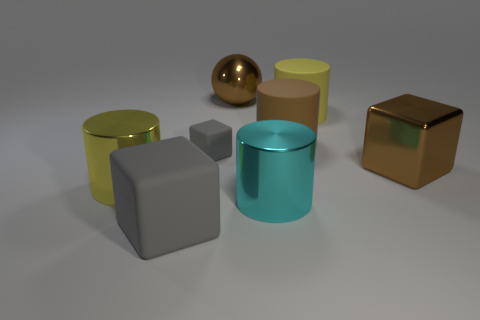Add 1 large brown metallic balls. How many objects exist? 9 Subtract all balls. How many objects are left? 7 Subtract 0 blue cylinders. How many objects are left? 8 Subtract all brown metallic blocks. Subtract all red metallic cubes. How many objects are left? 7 Add 3 brown shiny things. How many brown shiny things are left? 5 Add 6 yellow things. How many yellow things exist? 8 